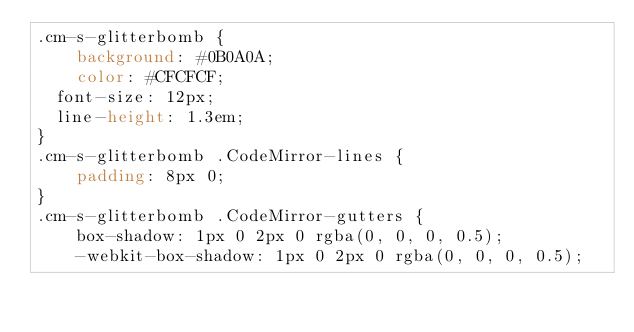Convert code to text. <code><loc_0><loc_0><loc_500><loc_500><_CSS_>.cm-s-glitterbomb {
	background: #0B0A0A;
	color: #CFCFCF;
  font-size: 12px;
  line-height: 1.3em;
}
.cm-s-glitterbomb .CodeMirror-lines {
	padding: 8px 0;
}
.cm-s-glitterbomb .CodeMirror-gutters {
	box-shadow: 1px 0 2px 0 rgba(0, 0, 0, 0.5);
	-webkit-box-shadow: 1px 0 2px 0 rgba(0, 0, 0, 0.5);</code> 